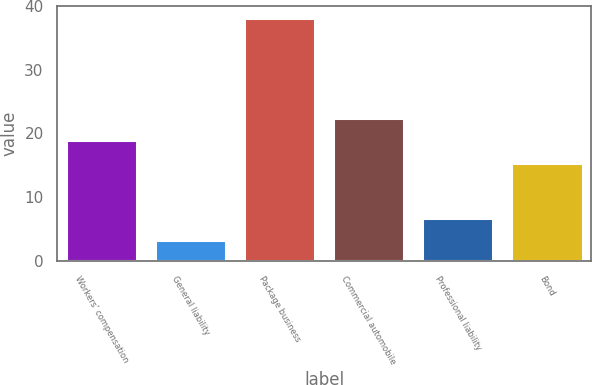Convert chart to OTSL. <chart><loc_0><loc_0><loc_500><loc_500><bar_chart><fcel>Workers' compensation<fcel>General liability<fcel>Package business<fcel>Commercial automobile<fcel>Professional liability<fcel>Bond<nl><fcel>18.88<fcel>3.3<fcel>38.1<fcel>22.36<fcel>6.78<fcel>15.4<nl></chart> 